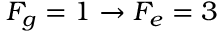Convert formula to latex. <formula><loc_0><loc_0><loc_500><loc_500>F _ { g } = 1 \rightarrow F _ { e } = 3</formula> 